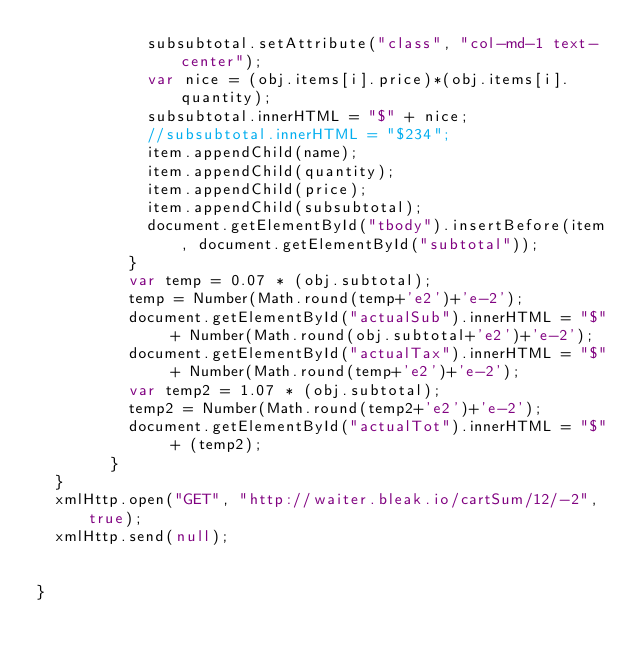<code> <loc_0><loc_0><loc_500><loc_500><_JavaScript_>            subsubtotal.setAttribute("class", "col-md-1 text-center");
            var nice = (obj.items[i].price)*(obj.items[i].quantity);
            subsubtotal.innerHTML = "$" + nice;
            //subsubtotal.innerHTML = "$234";
            item.appendChild(name);
            item.appendChild(quantity);
            item.appendChild(price);
            item.appendChild(subsubtotal);
            document.getElementById("tbody").insertBefore(item, document.getElementById("subtotal"));
          }
          var temp = 0.07 * (obj.subtotal);
          temp = Number(Math.round(temp+'e2')+'e-2');
          document.getElementById("actualSub").innerHTML = "$" + Number(Math.round(obj.subtotal+'e2')+'e-2');
          document.getElementById("actualTax").innerHTML = "$" + Number(Math.round(temp+'e2')+'e-2');
          var temp2 = 1.07 * (obj.subtotal);
          temp2 = Number(Math.round(temp2+'e2')+'e-2');
          document.getElementById("actualTot").innerHTML = "$" + (temp2);
        }
  }
  xmlHttp.open("GET", "http://waiter.bleak.io/cartSum/12/-2", true);
  xmlHttp.send(null);


}
</code> 